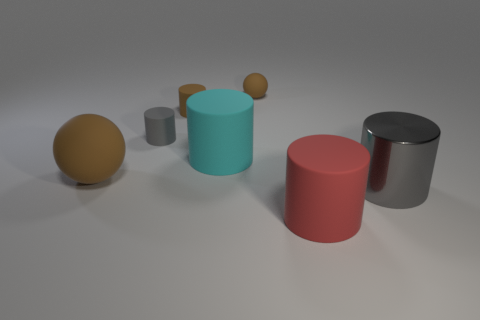There is another large rubber object that is the same shape as the red rubber thing; what is its color?
Keep it short and to the point. Cyan. What is the color of the large cylinder that is made of the same material as the big cyan object?
Offer a very short reply. Red. Are there any large matte spheres that are behind the ball that is left of the matte ball on the right side of the big cyan rubber cylinder?
Your answer should be compact. No. Is the number of shiny objects that are on the left side of the small gray cylinder less than the number of red things that are in front of the large gray cylinder?
Your response must be concise. Yes. How many purple cubes have the same material as the tiny gray cylinder?
Keep it short and to the point. 0. There is a metallic thing; is it the same size as the brown matte ball that is on the right side of the big brown rubber ball?
Provide a succinct answer. No. There is a gray metallic cylinder in front of the brown matte sphere that is in front of the gray object that is to the left of the big red matte thing; what is its size?
Make the answer very short. Large. Are there more things that are behind the large cyan rubber object than red cylinders that are to the right of the large red rubber cylinder?
Provide a short and direct response. Yes. There is a gray cylinder on the left side of the red object; what number of red matte things are on the left side of it?
Your response must be concise. 0. Is there another cylinder that has the same color as the metal cylinder?
Offer a very short reply. Yes. 